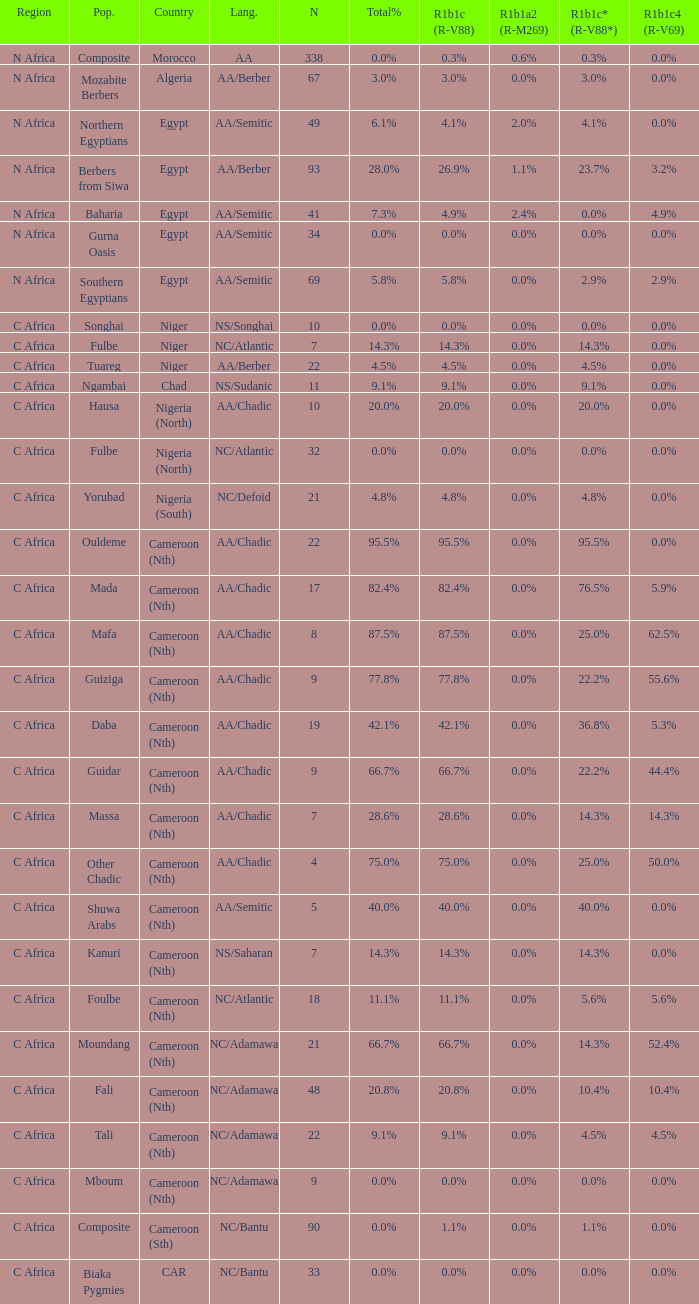What is the largest n value for 55.6% r1b1c4 (r-v69)? 9.0. 